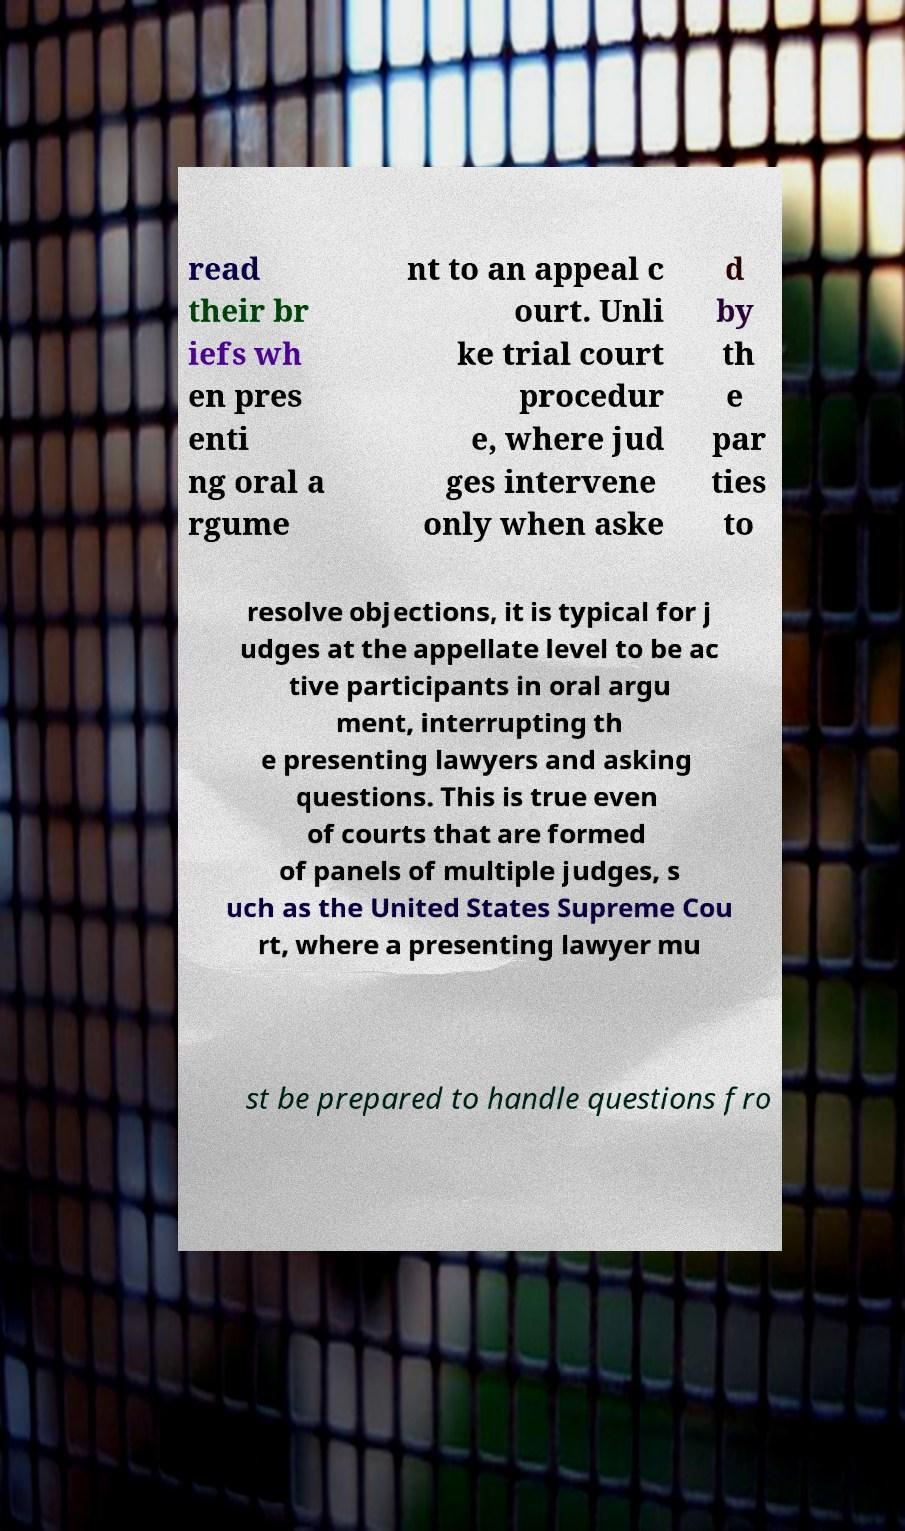Could you assist in decoding the text presented in this image and type it out clearly? read their br iefs wh en pres enti ng oral a rgume nt to an appeal c ourt. Unli ke trial court procedur e, where jud ges intervene only when aske d by th e par ties to resolve objections, it is typical for j udges at the appellate level to be ac tive participants in oral argu ment, interrupting th e presenting lawyers and asking questions. This is true even of courts that are formed of panels of multiple judges, s uch as the United States Supreme Cou rt, where a presenting lawyer mu st be prepared to handle questions fro 